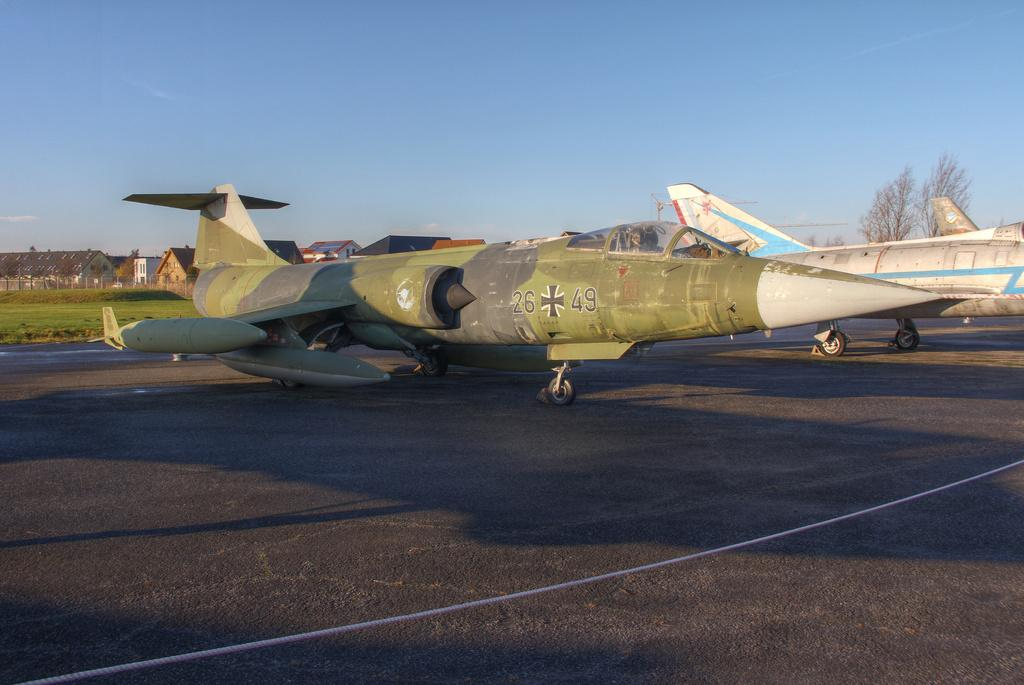<image>
Describe the image concisely. An old jet has the numbers 26 and 49 on the side, with a symbol in between. 